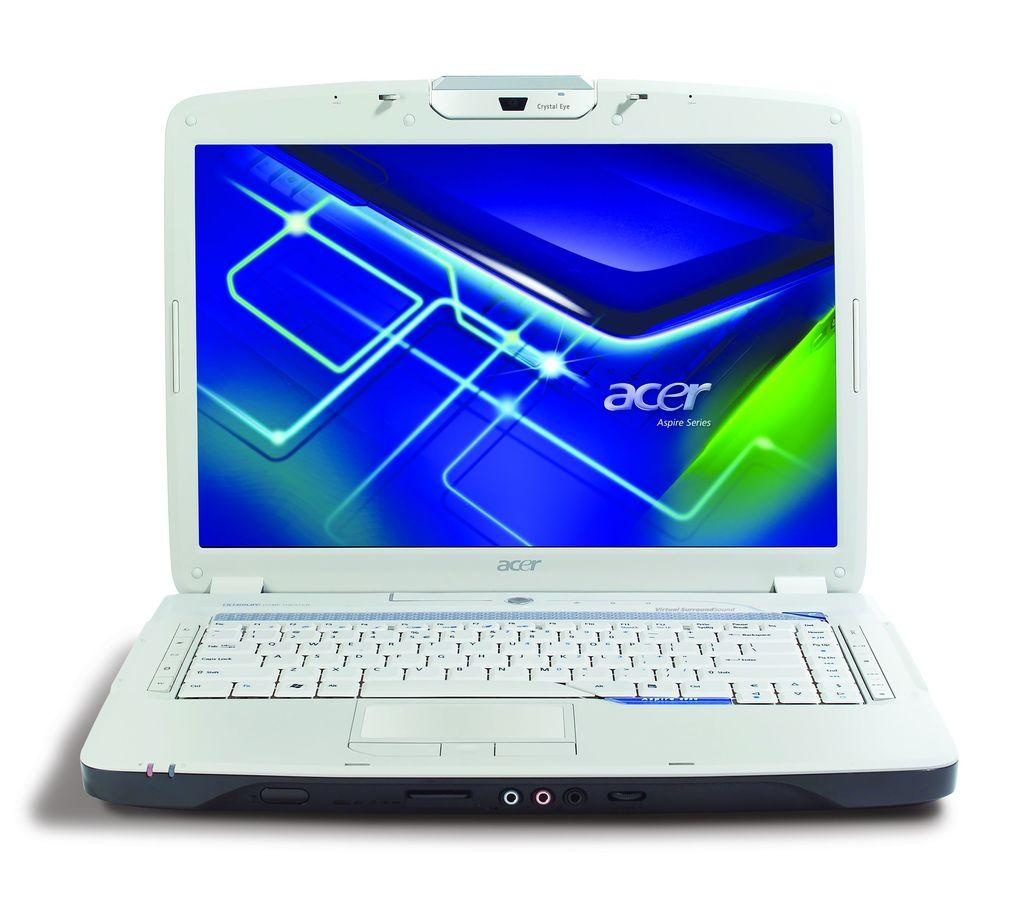<image>
Relay a brief, clear account of the picture shown. A computer shows the brand Acer on the screen. 